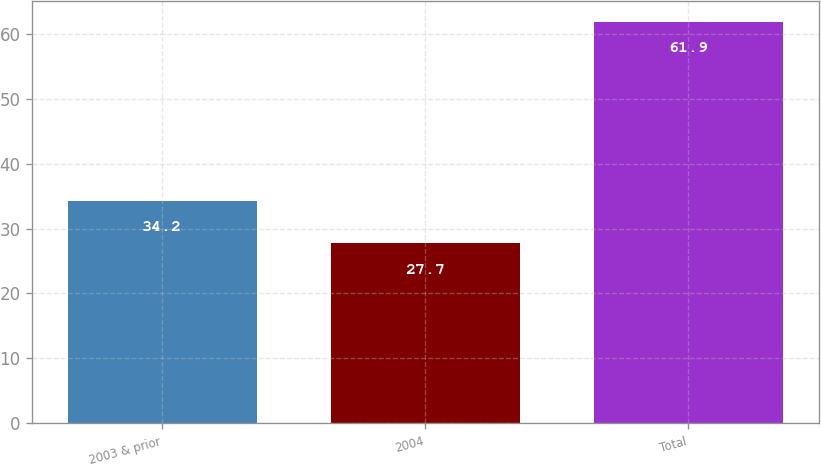Convert chart to OTSL. <chart><loc_0><loc_0><loc_500><loc_500><bar_chart><fcel>2003 & prior<fcel>2004<fcel>Total<nl><fcel>34.2<fcel>27.7<fcel>61.9<nl></chart> 